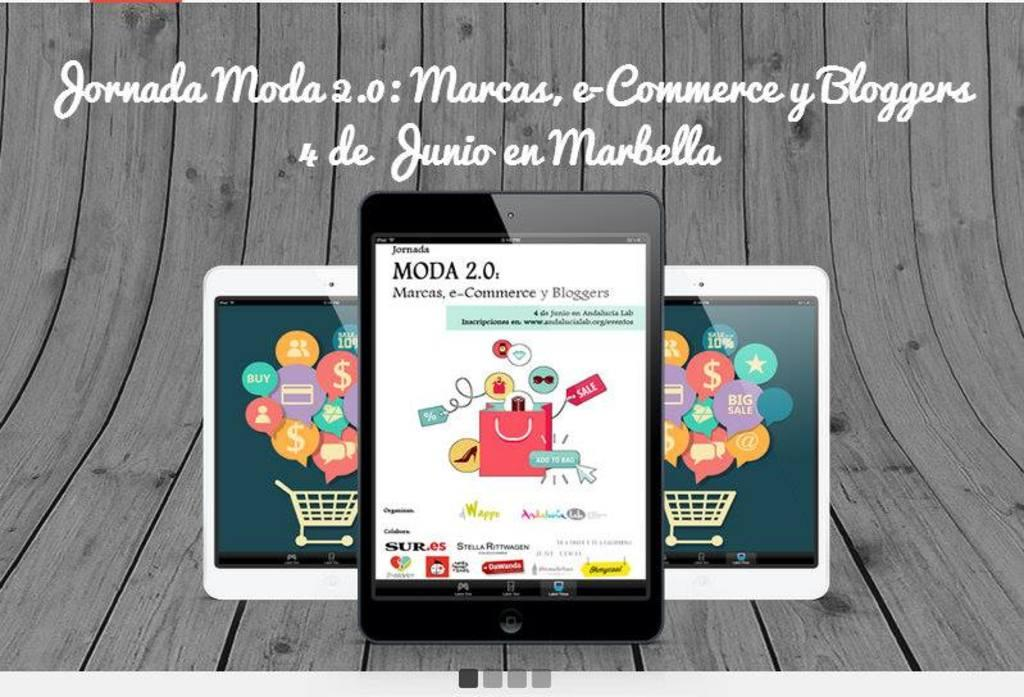<image>
Share a concise interpretation of the image provided. three ipads with words on top of them that say 'jornada moda 2.0' 